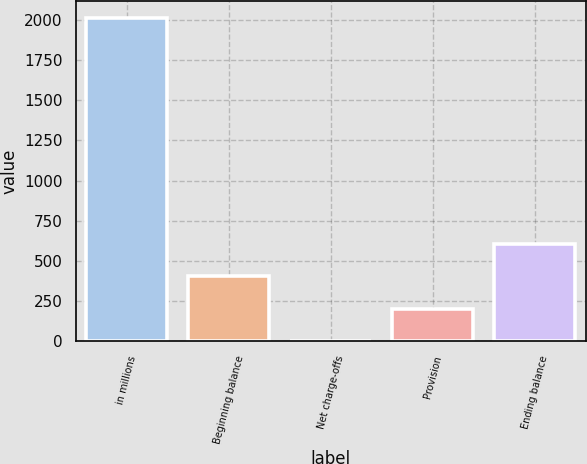Convert chart. <chart><loc_0><loc_0><loc_500><loc_500><bar_chart><fcel>in millions<fcel>Beginning balance<fcel>Net charge-offs<fcel>Provision<fcel>Ending balance<nl><fcel>2015<fcel>403.8<fcel>1<fcel>202.4<fcel>605.2<nl></chart> 